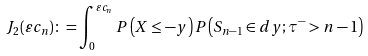Convert formula to latex. <formula><loc_0><loc_0><loc_500><loc_500>J _ { 2 } ( \varepsilon c _ { n } ) \colon = \int _ { 0 } ^ { \varepsilon c _ { n } } P \left ( X \leq - y \right ) P \left ( S _ { n - 1 } \in d y ; \tau ^ { - } > n - 1 \right )</formula> 